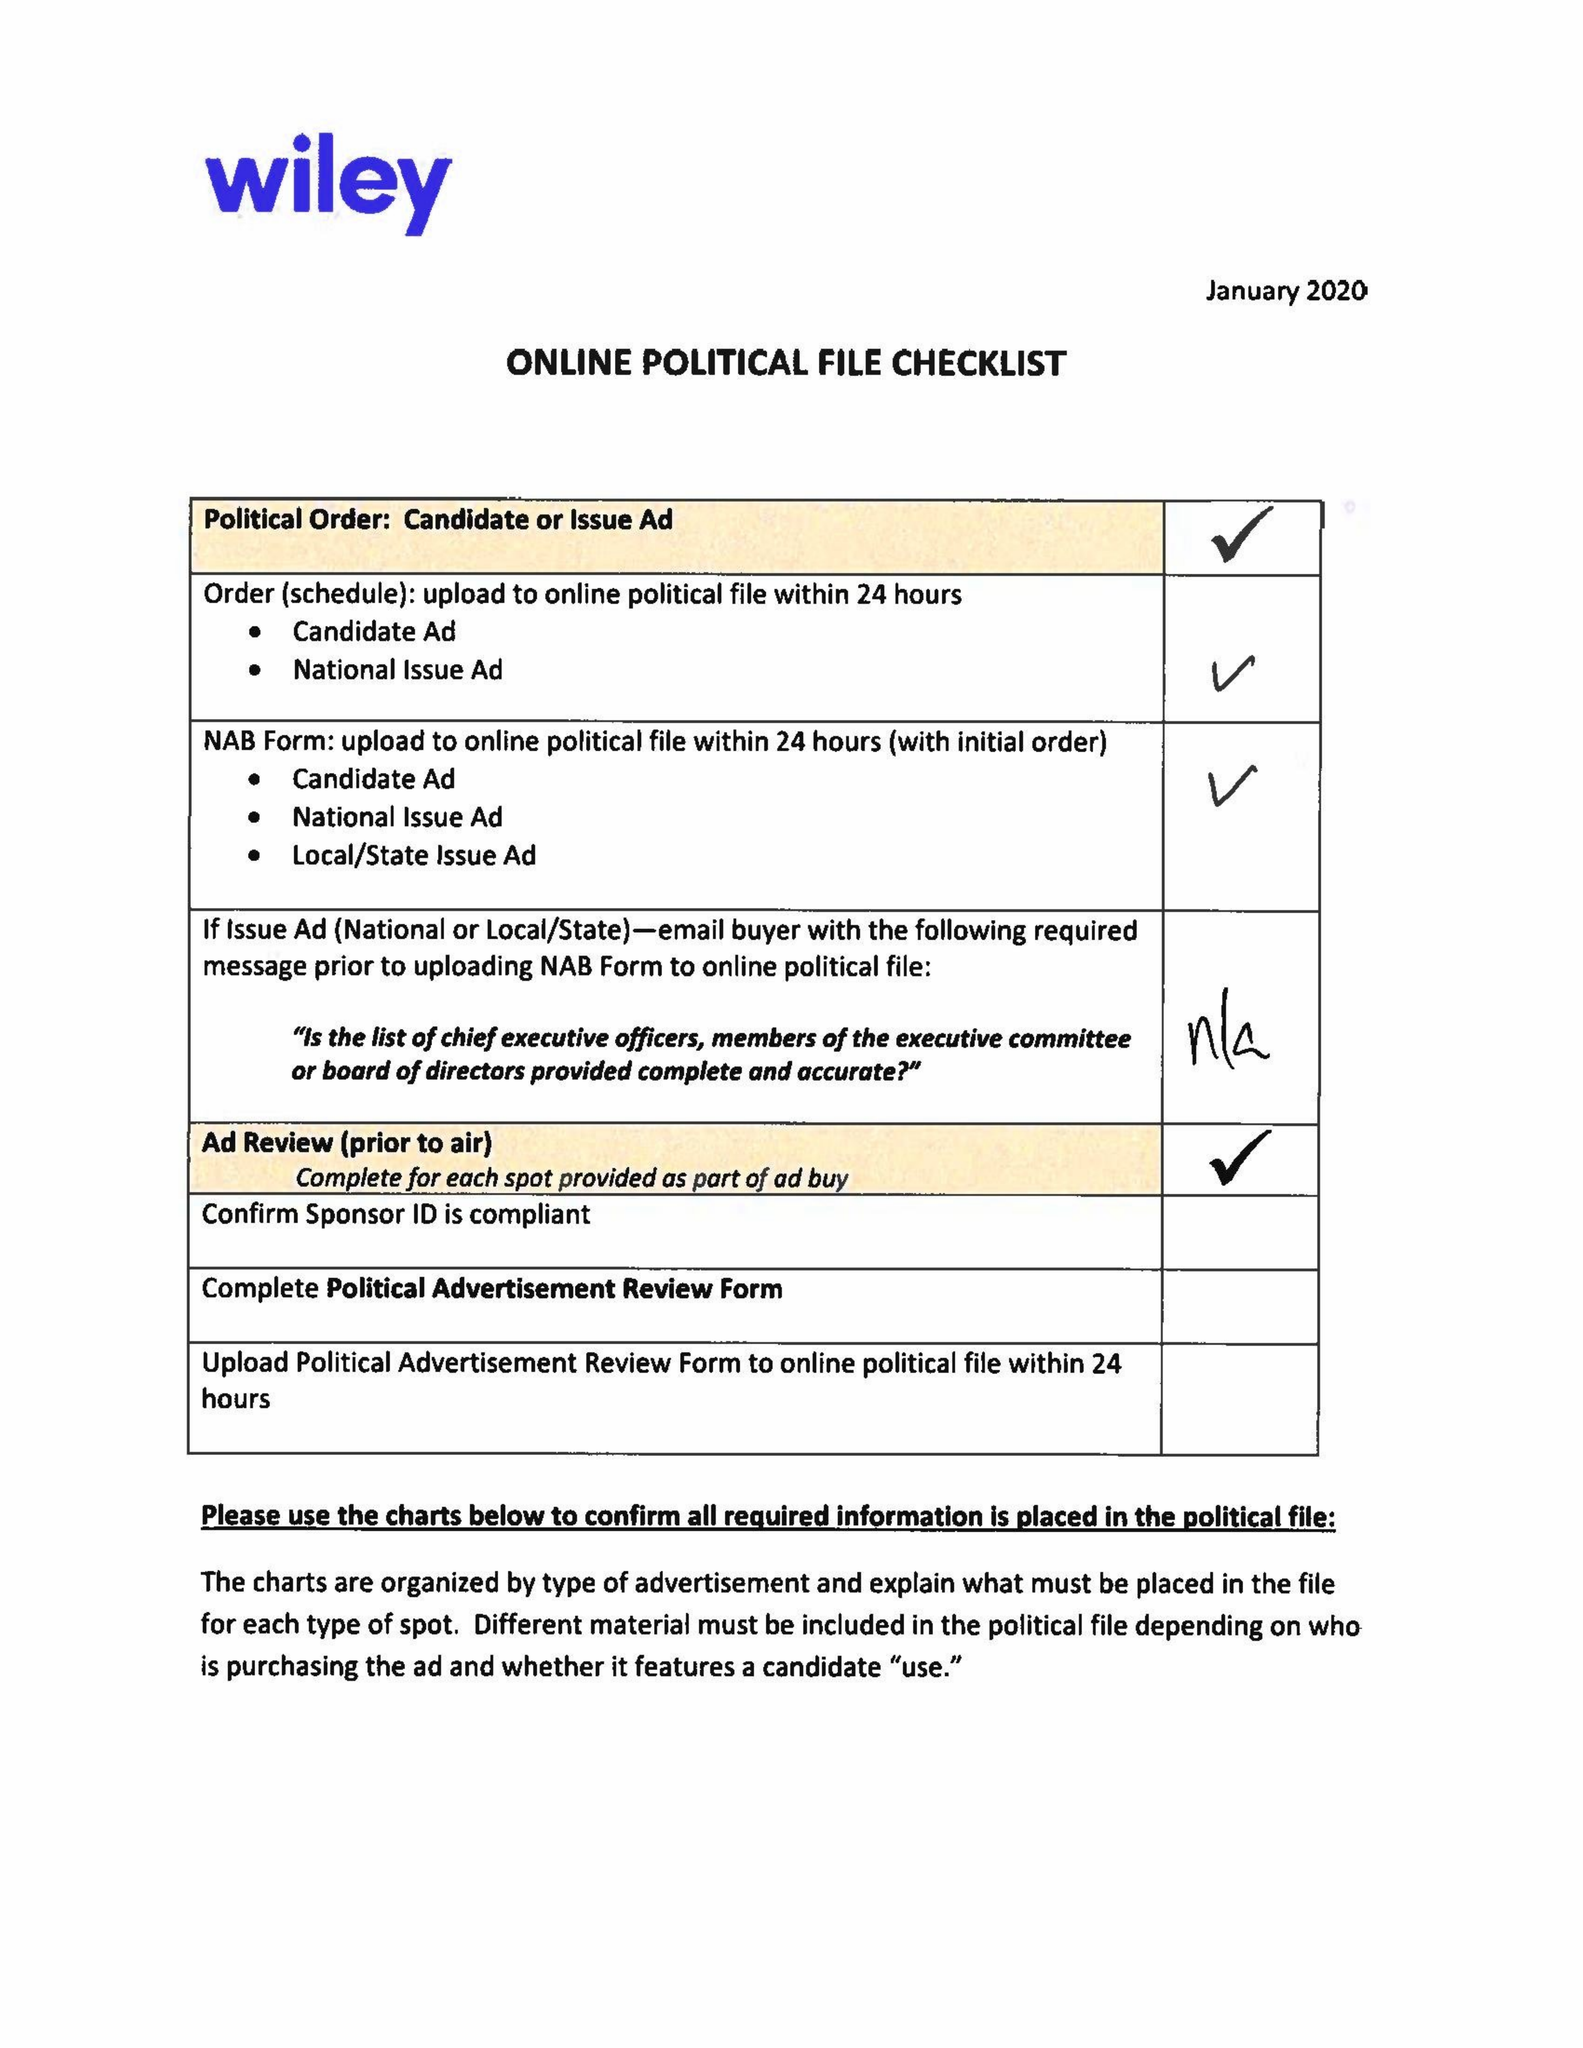What is the value for the advertiser?
Answer the question using a single word or phrase. CAM WARD FOR AL SUPREME COURT 